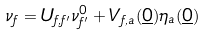Convert formula to latex. <formula><loc_0><loc_0><loc_500><loc_500>\nu _ { f } = U _ { f , f ^ { \prime } } \nu ^ { 0 } _ { f ^ { \prime } } + V _ { f , a } ( \underline { 0 } ) \eta _ { a } ( \underline { 0 } )</formula> 